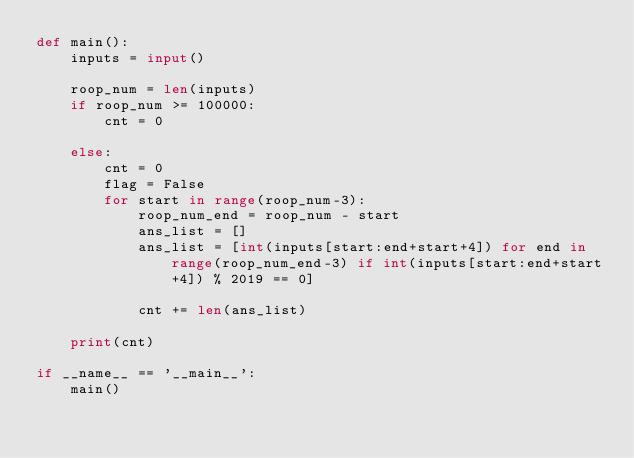Convert code to text. <code><loc_0><loc_0><loc_500><loc_500><_Python_>def main():
    inputs = input()

    roop_num = len(inputs)
    if roop_num >= 100000:
        cnt = 0

    else:
        cnt = 0
        flag = False
        for start in range(roop_num-3):
            roop_num_end = roop_num - start
            ans_list = []
            ans_list = [int(inputs[start:end+start+4]) for end in range(roop_num_end-3) if int(inputs[start:end+start+4]) % 2019 == 0]

            cnt += len(ans_list)

    print(cnt)

if __name__ == '__main__':
    main()</code> 